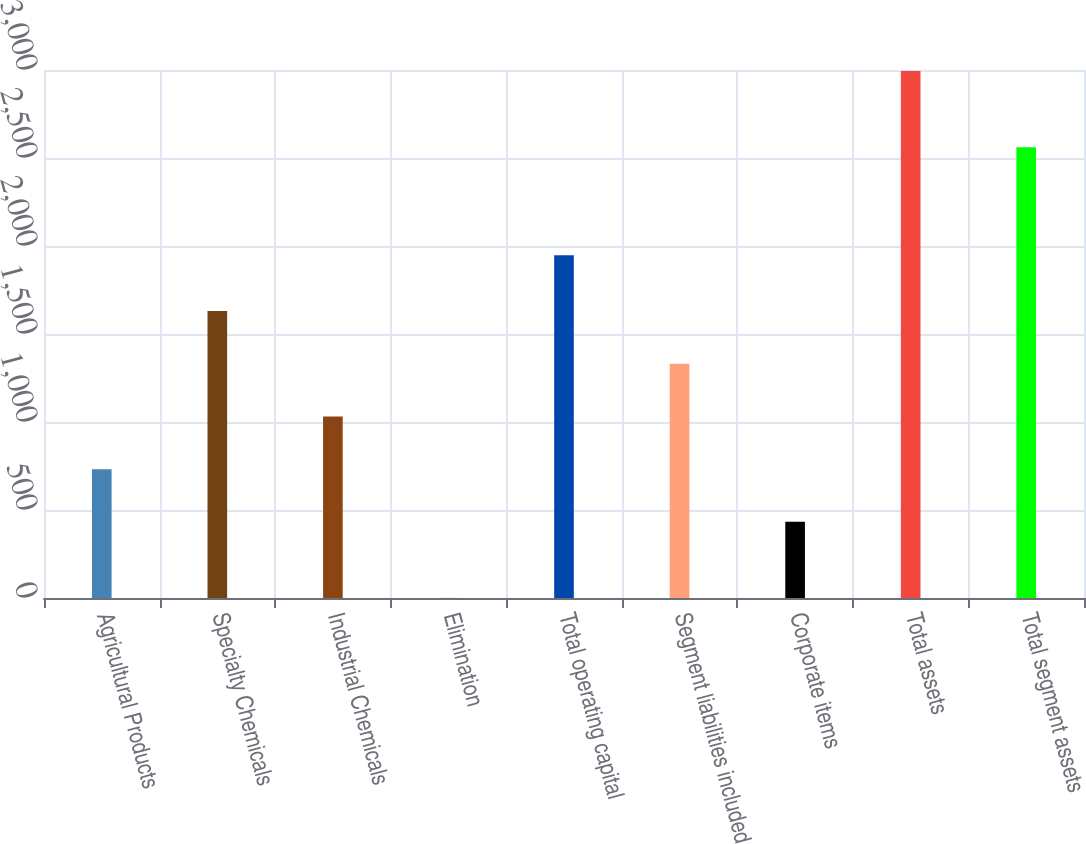Convert chart to OTSL. <chart><loc_0><loc_0><loc_500><loc_500><bar_chart><fcel>Agricultural Products<fcel>Specialty Chemicals<fcel>Industrial Chemicals<fcel>Elimination<fcel>Total operating capital<fcel>Segment liabilities included<fcel>Corporate items<fcel>Total assets<fcel>Total segment assets<nl><fcel>731.95<fcel>1630<fcel>1031.3<fcel>0.4<fcel>1947.6<fcel>1330.65<fcel>432.6<fcel>2993.9<fcel>2561.3<nl></chart> 